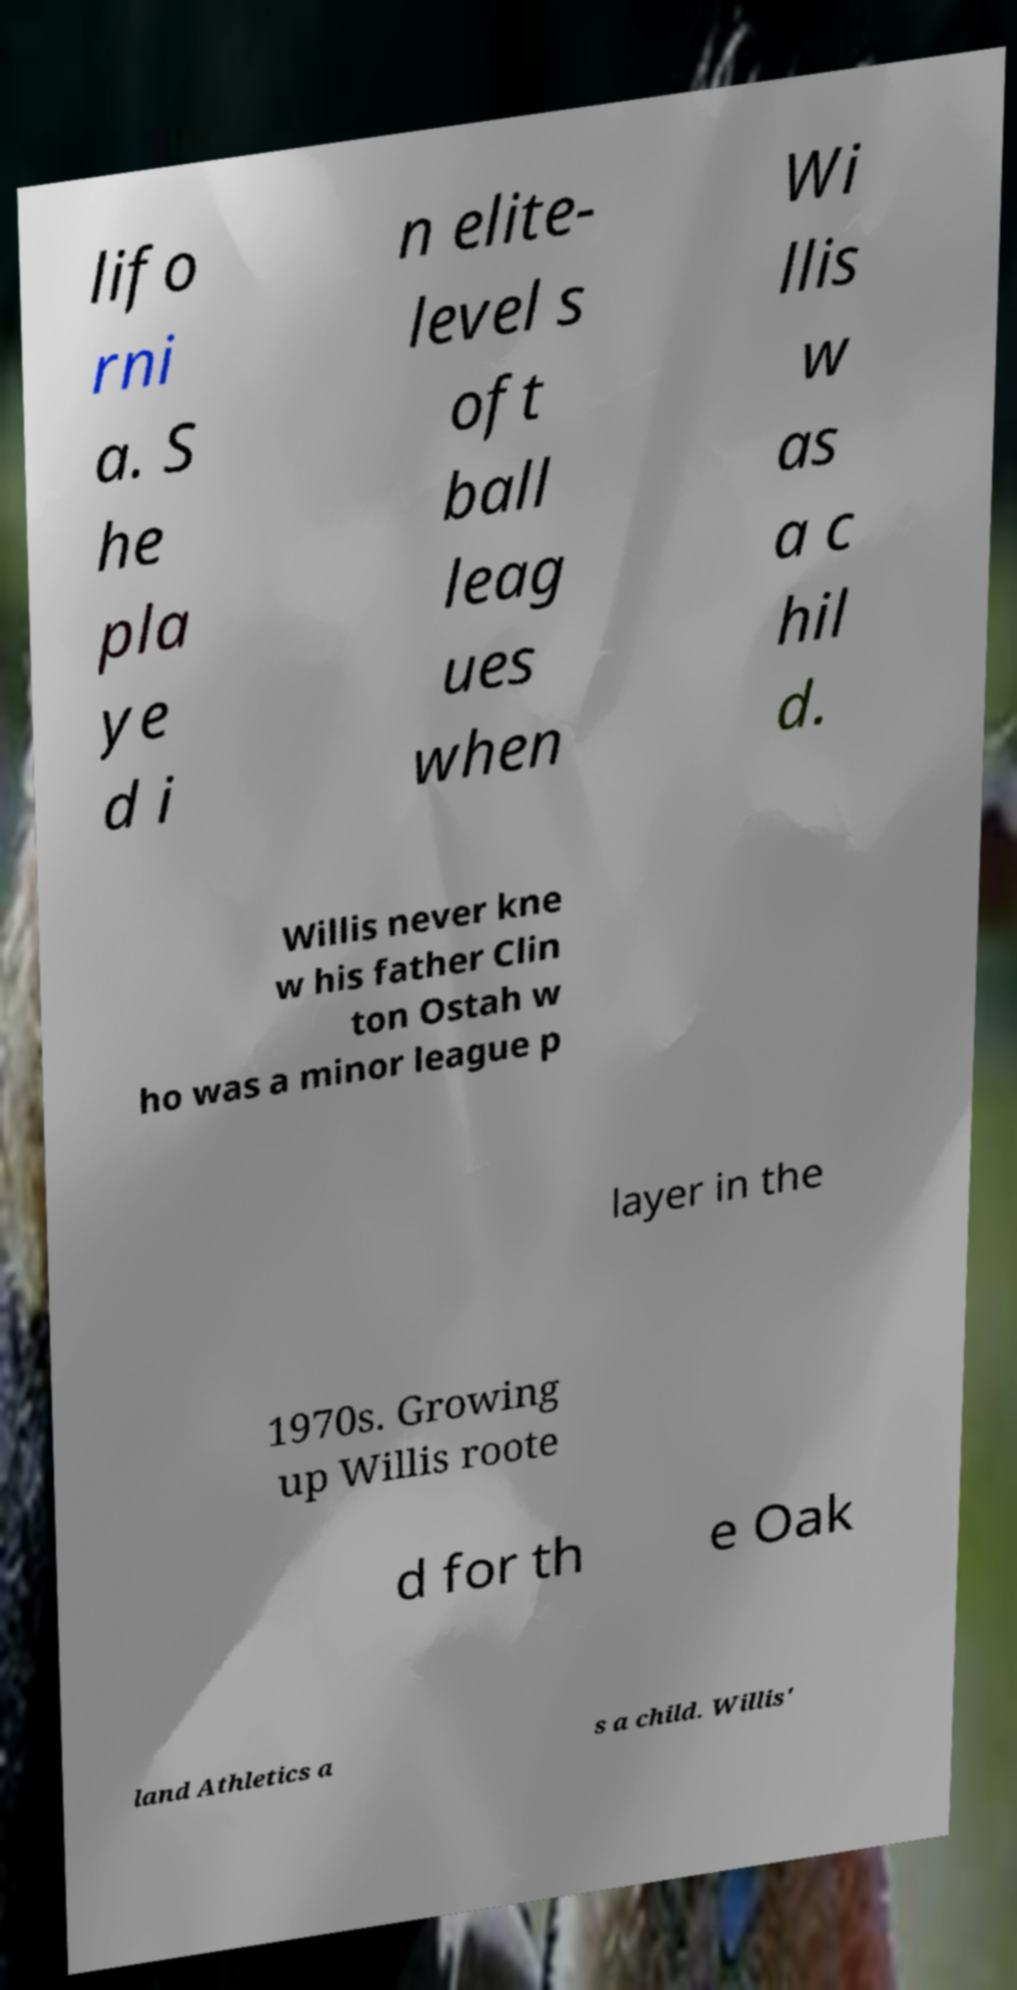Could you assist in decoding the text presented in this image and type it out clearly? lifo rni a. S he pla ye d i n elite- level s oft ball leag ues when Wi llis w as a c hil d. Willis never kne w his father Clin ton Ostah w ho was a minor league p layer in the 1970s. Growing up Willis roote d for th e Oak land Athletics a s a child. Willis' 